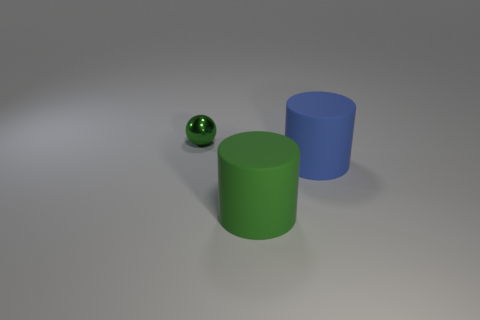Is there any other thing that has the same material as the tiny object?
Ensure brevity in your answer.  No. Does the large thing that is on the left side of the blue cylinder have the same material as the object behind the blue thing?
Keep it short and to the point. No. There is a blue thing that is the same material as the big green cylinder; what size is it?
Provide a short and direct response. Large. What is the shape of the thing that is in front of the blue object?
Offer a terse response. Cylinder. There is a tiny shiny object that is behind the green matte thing; is it the same color as the large object that is to the left of the blue cylinder?
Offer a terse response. Yes. Are any shiny cylinders visible?
Your answer should be very brief. No. What is the shape of the large thing in front of the rubber object that is to the right of the green thing in front of the tiny green thing?
Ensure brevity in your answer.  Cylinder. There is a big blue cylinder; how many large cylinders are on the left side of it?
Keep it short and to the point. 1. Are the large cylinder that is on the right side of the green cylinder and the small green thing made of the same material?
Offer a very short reply. No. What number of other things are the same shape as the tiny green metal object?
Provide a succinct answer. 0. 